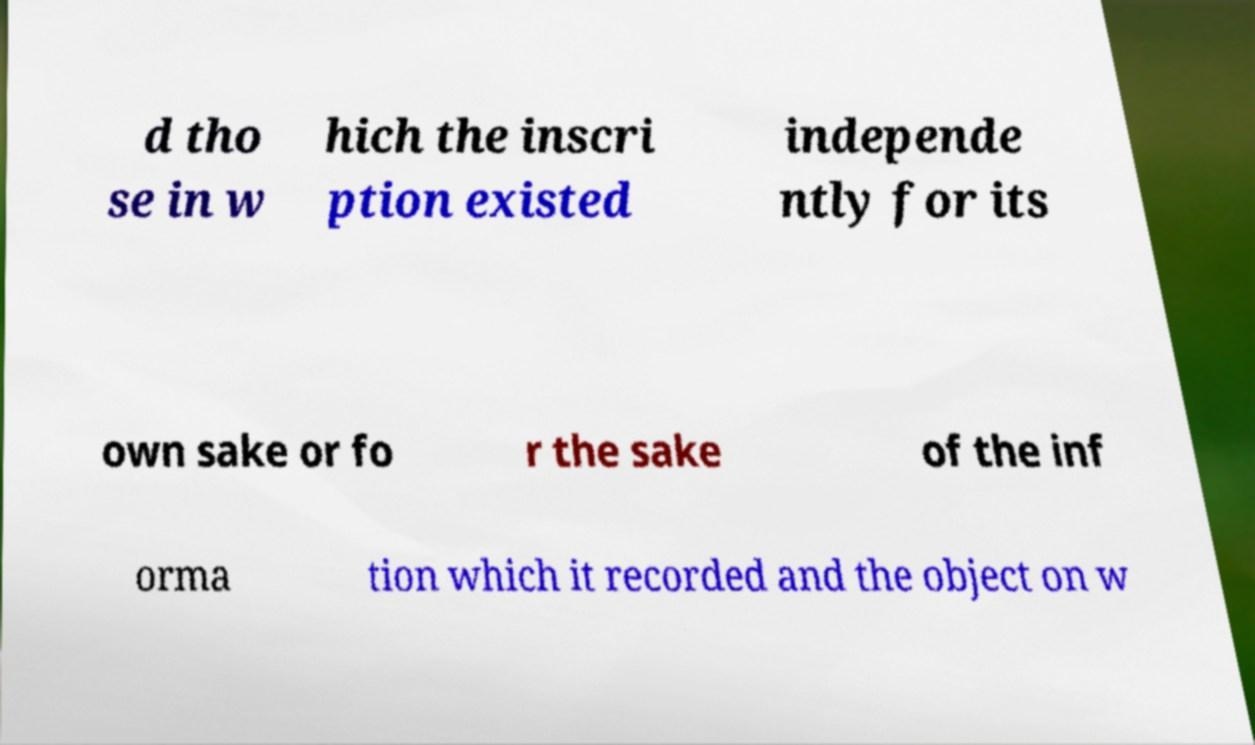For documentation purposes, I need the text within this image transcribed. Could you provide that? d tho se in w hich the inscri ption existed independe ntly for its own sake or fo r the sake of the inf orma tion which it recorded and the object on w 